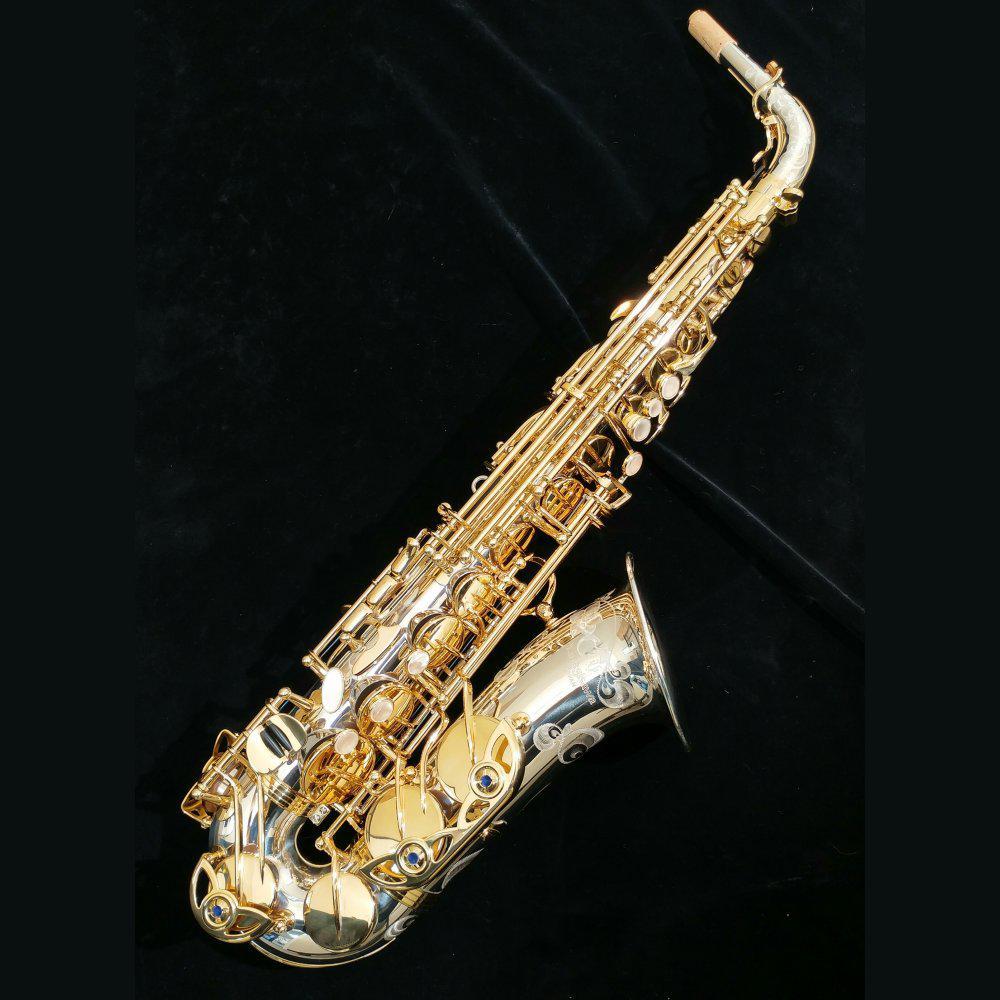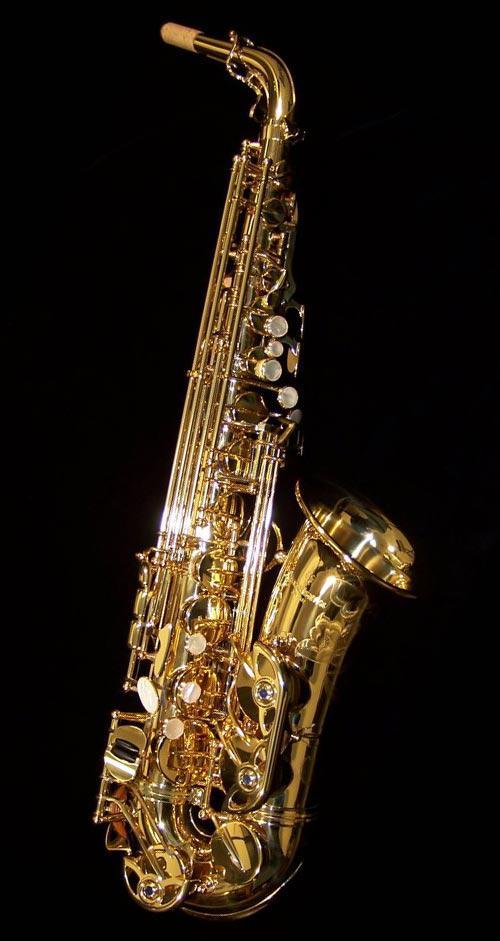The first image is the image on the left, the second image is the image on the right. Evaluate the accuracy of this statement regarding the images: "all instruments are fully upright". Is it true? Answer yes or no. No. 